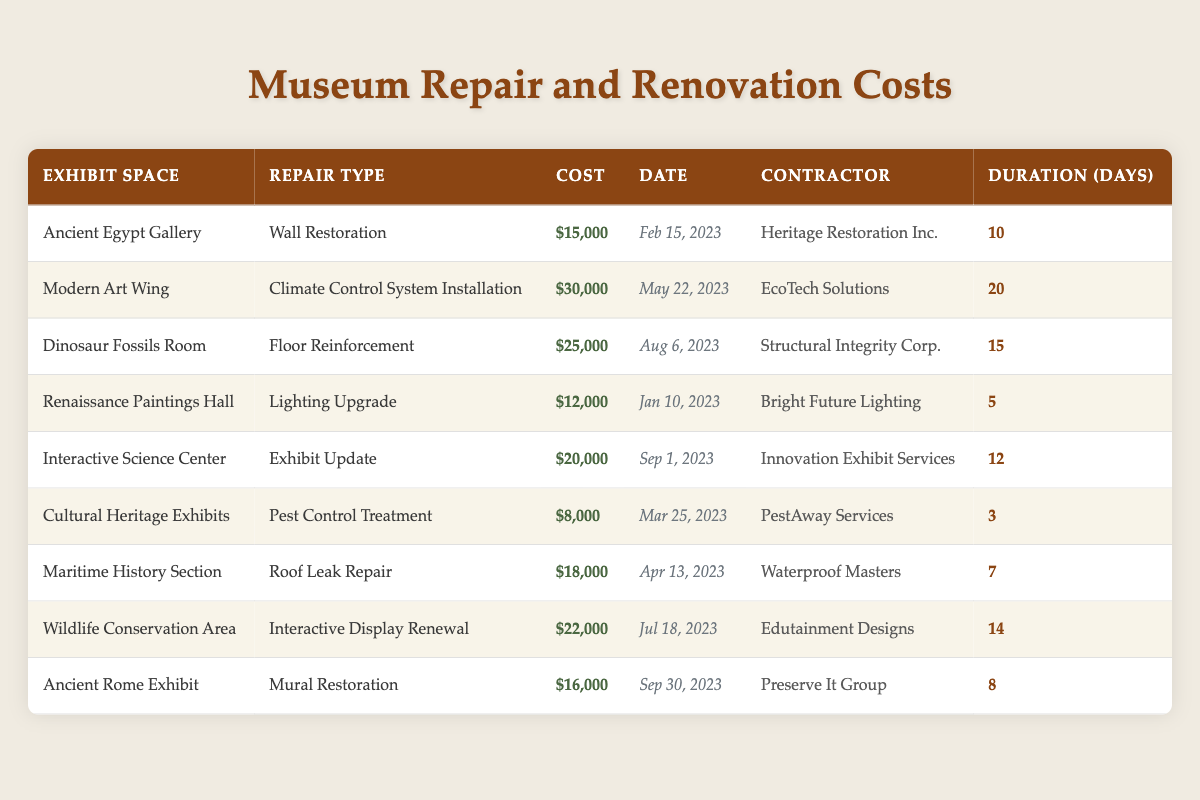What is the total cost for repairs in the Ancient Egypt Gallery? The cost for repairs in the Ancient Egypt Gallery is listed as $15,000. There are no other entries for this exhibit, so the total cost remains the same.
Answer: $15,000 What repair type was done in the Modern Art Wing? The repair type for the Modern Art Wing is listed as "Climate Control System Installation." This information can be found directly under the corresponding entry in the table.
Answer: Climate Control System Installation Which contractor handled the Pest Control Treatment in the Cultural Heritage Exhibits? The contractor for the Pest Control Treatment in the Cultural Heritage Exhibits is "PestAway Services," as indicated in the contractor column for this repair type.
Answer: PestAway Services How much did the Interactive Display Renewal cost? The cost of the Interactive Display Renewal for the Wildlife Conservation Area is listed as $22,000 in the cost column of the table.
Answer: $22,000 What is the average duration of repairs across all exhibit spaces? To find the average duration, sum all the durations (10 + 20 + 15 + 5 + 12 + 3 + 7 + 14 + 8 = 94 days) and divide by the number of repairs (9), yielding an average of 94/9 ≈ 10.44.
Answer: Approximately 10.44 days Did any repairs cost less than $10,000? There is one instance of a repair costing less than $10,000: the Pest Control Treatment in the Cultural Heritage Exhibits, which cost $8,000. This is confirmed by checking the cost values in the table.
Answer: Yes How much more expensive was the Climate Control System Installation compared to the Wall Restoration? The Climate Control System Installation cost is $30,000, while the Wall Restoration cost is $15,000. The difference is $30,000 - $15,000 = $15,000.
Answer: $15,000 What is the total cost of all repairs done in 2023? The total cost for all repairs in 2023 can be calculated by summing all individual repair costs: $15,000 + $30,000 + $25,000 + $12,000 + $20,000 + $8,000 + $18,000 + $22,000 + $16,000 = $ 156,000.
Answer: $156,000 Which repair had the longest duration, and how long did it take? The longest duration listed is for the Climate Control System Installation, lasting 20 days as shown in the duration column.
Answer: 20 days What is the difference in cost between the least and most expensive repairs? The least expensive repair is the Pest Control Treatment at $8,000, and the most expensive is the Climate Control System Installation at $30,000. The difference is $30,000 - $8,000 = $22,000.
Answer: $22,000 